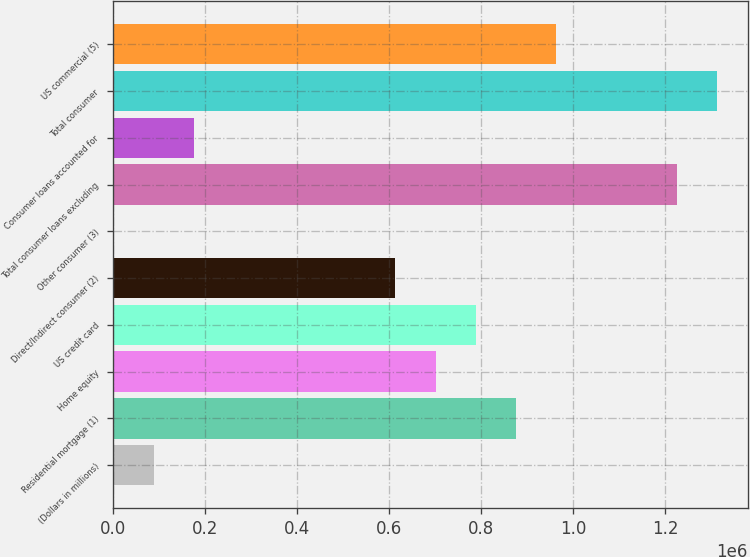<chart> <loc_0><loc_0><loc_500><loc_500><bar_chart><fcel>(Dollars in millions)<fcel>Residential mortgage (1)<fcel>Home equity<fcel>US credit card<fcel>Direct/Indirect consumer (2)<fcel>Other consumer (3)<fcel>Total consumer loans excluding<fcel>Consumer loans accounted for<fcel>Total consumer<fcel>US commercial (5)<nl><fcel>89271.8<fcel>876104<fcel>701252<fcel>788678<fcel>613827<fcel>1846<fcel>1.22581e+06<fcel>176698<fcel>1.31323e+06<fcel>963530<nl></chart> 